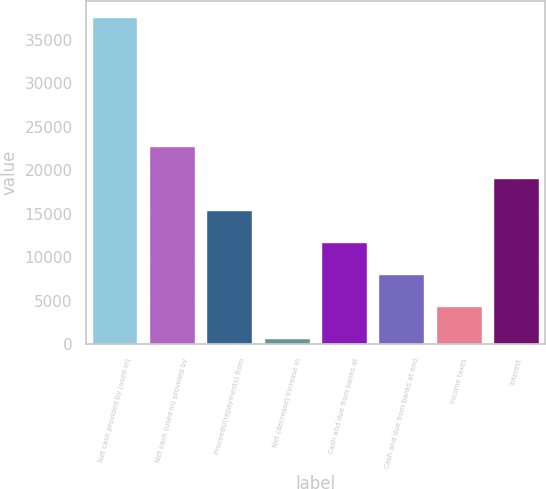<chart> <loc_0><loc_0><loc_500><loc_500><bar_chart><fcel>Net cash provided by (used in)<fcel>Net cash (used in) provided by<fcel>Proceeds/(repayments) from<fcel>Net (decrease) increase in<fcel>Cash and due from banks at<fcel>Cash and due from banks at end<fcel>Income taxes<fcel>Interest<nl><fcel>37603<fcel>22857.8<fcel>15485.2<fcel>740<fcel>11798.9<fcel>8112.6<fcel>4426.3<fcel>19171.5<nl></chart> 